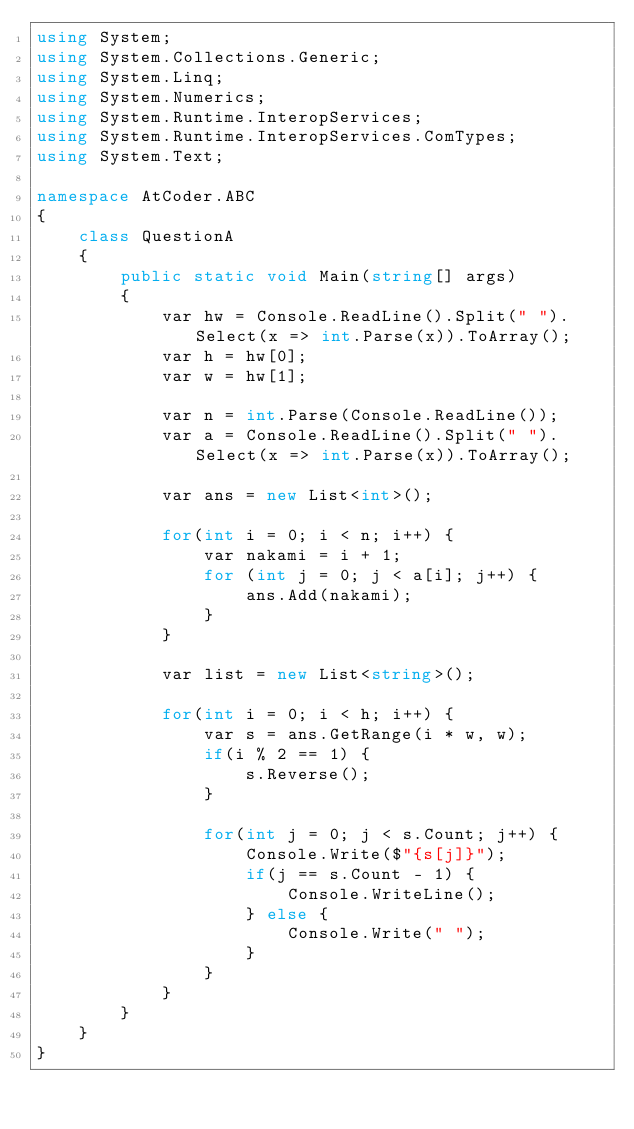Convert code to text. <code><loc_0><loc_0><loc_500><loc_500><_C#_>using System;
using System.Collections.Generic;
using System.Linq;
using System.Numerics;
using System.Runtime.InteropServices;
using System.Runtime.InteropServices.ComTypes;
using System.Text;

namespace AtCoder.ABC
{
    class QuestionA
    {
        public static void Main(string[] args)
        {
            var hw = Console.ReadLine().Split(" ").Select(x => int.Parse(x)).ToArray();
            var h = hw[0];
            var w = hw[1];

            var n = int.Parse(Console.ReadLine());
            var a = Console.ReadLine().Split(" ").Select(x => int.Parse(x)).ToArray();

            var ans = new List<int>();

            for(int i = 0; i < n; i++) {
                var nakami = i + 1;
                for (int j = 0; j < a[i]; j++) {
                    ans.Add(nakami);
				}
			}

            var list = new List<string>();

            for(int i = 0; i < h; i++) {
                var s = ans.GetRange(i * w, w);
                if(i % 2 == 1) {
                    s.Reverse();
				}

                for(int j = 0; j < s.Count; j++) {
                    Console.Write($"{s[j]}");
                    if(j == s.Count - 1) {
                        Console.WriteLine();
					} else {
                        Console.Write(" ");
					}
				}
			}
        }
    }
}

</code> 